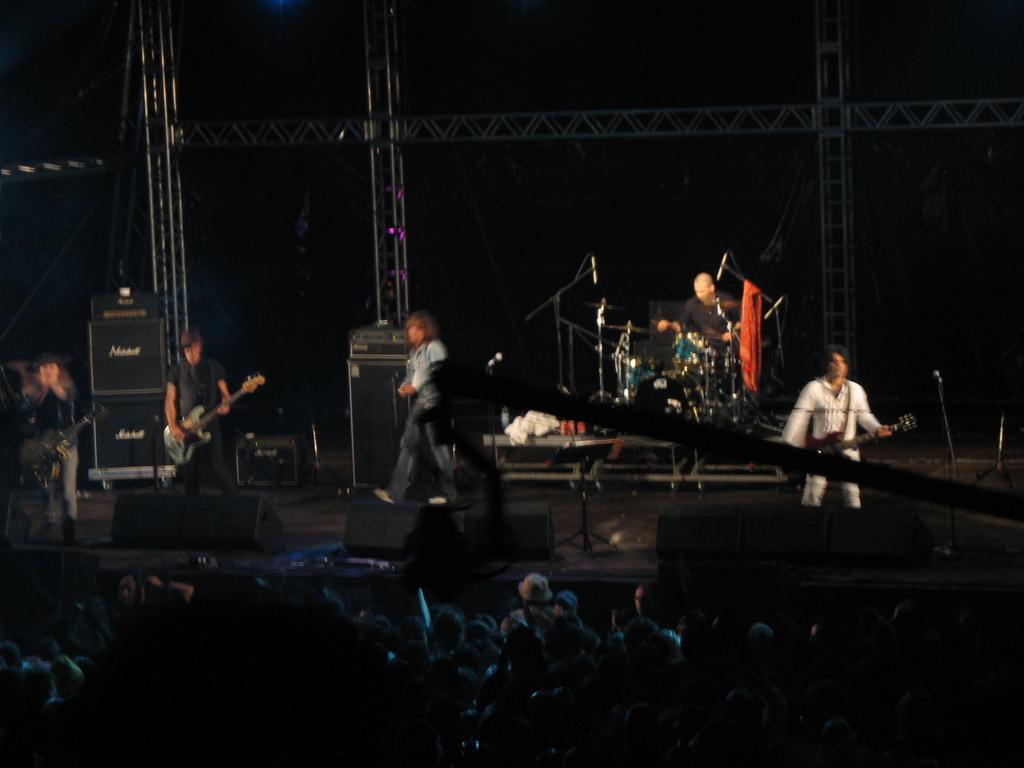Please provide a concise description of this image. In the image there are few persons standing on stage and playing musical instruments, in the front there are many audience standing and staring at the front. 